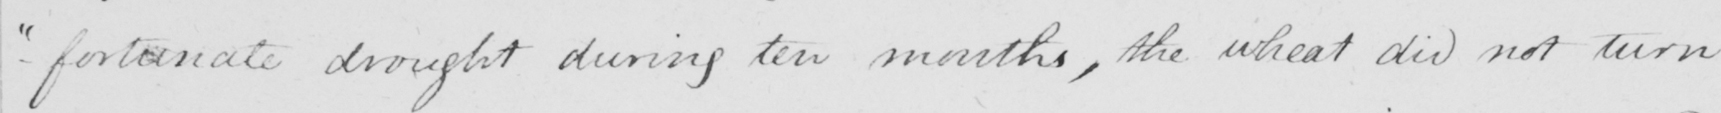What is written in this line of handwriting? -fortunate drought during ten months , the wheat did not turn 